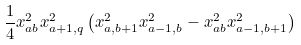<formula> <loc_0><loc_0><loc_500><loc_500>\frac { 1 } { 4 } x _ { a b } ^ { 2 } x _ { a + 1 , q } ^ { 2 } \left ( x _ { a , b + 1 } ^ { 2 } x _ { a - 1 , b } ^ { 2 } - x _ { a b } ^ { 2 } x _ { a - 1 , b + 1 } ^ { 2 } \right )</formula> 